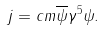Convert formula to latex. <formula><loc_0><loc_0><loc_500><loc_500>j = c m \overline { \psi } \gamma ^ { 5 } \psi .</formula> 